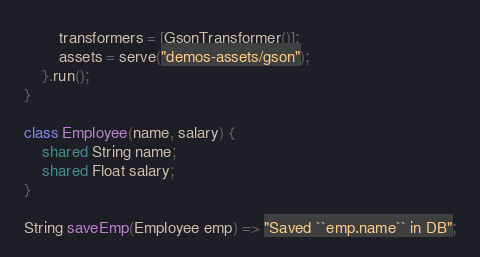Convert code to text. <code><loc_0><loc_0><loc_500><loc_500><_Ceylon_>        transformers = [GsonTransformer()];
        assets = serve("demos-assets/gson");
    }.run();
}

class Employee(name, salary) {
    shared String name;
    shared Float salary;    
}

String saveEmp(Employee emp) => "Saved ``emp.name`` in DB";</code> 